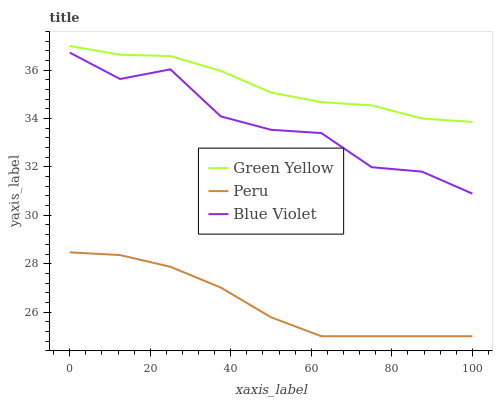Does Peru have the minimum area under the curve?
Answer yes or no. Yes. Does Green Yellow have the maximum area under the curve?
Answer yes or no. Yes. Does Blue Violet have the minimum area under the curve?
Answer yes or no. No. Does Blue Violet have the maximum area under the curve?
Answer yes or no. No. Is Peru the smoothest?
Answer yes or no. Yes. Is Blue Violet the roughest?
Answer yes or no. Yes. Is Blue Violet the smoothest?
Answer yes or no. No. Is Peru the roughest?
Answer yes or no. No. Does Peru have the lowest value?
Answer yes or no. Yes. Does Blue Violet have the lowest value?
Answer yes or no. No. Does Green Yellow have the highest value?
Answer yes or no. Yes. Does Blue Violet have the highest value?
Answer yes or no. No. Is Peru less than Green Yellow?
Answer yes or no. Yes. Is Green Yellow greater than Blue Violet?
Answer yes or no. Yes. Does Peru intersect Green Yellow?
Answer yes or no. No. 